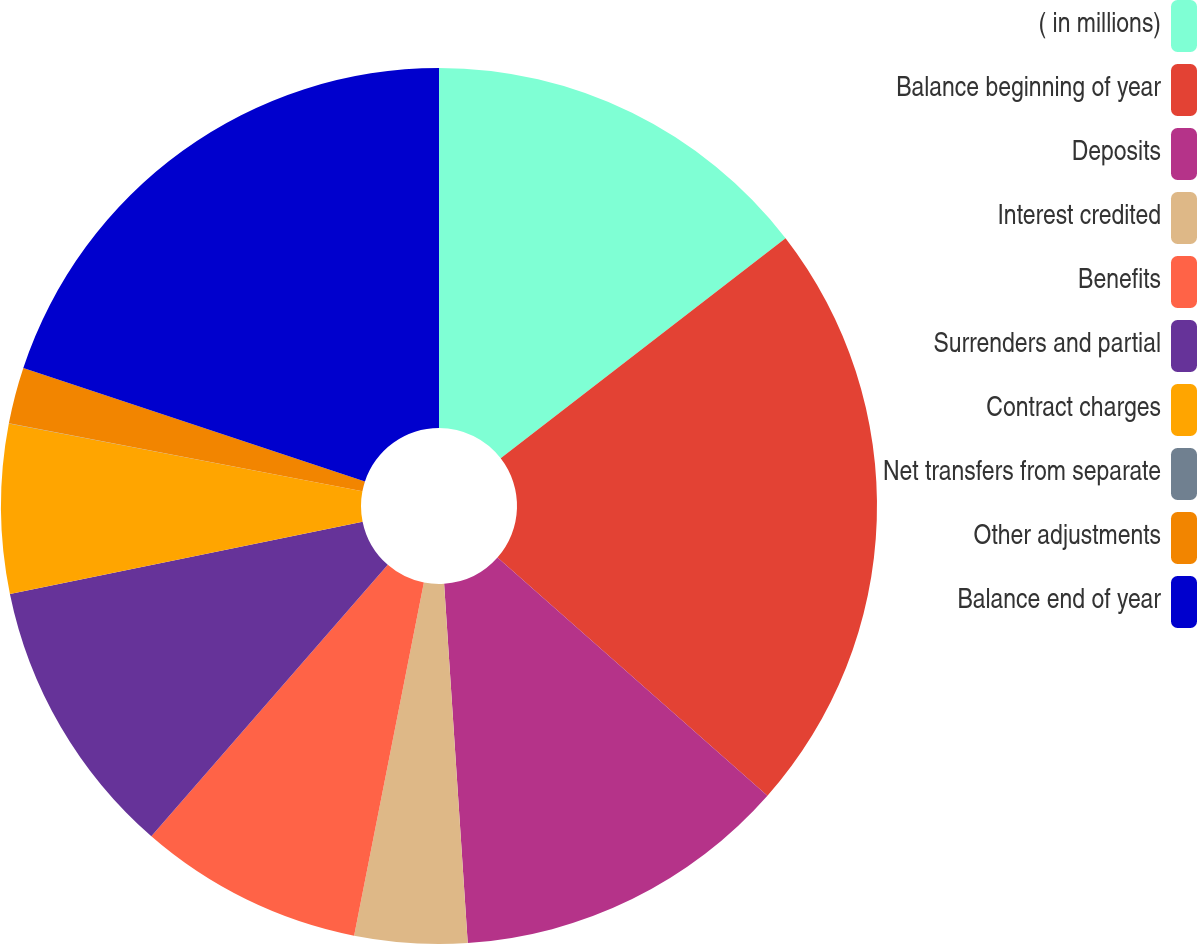Convert chart. <chart><loc_0><loc_0><loc_500><loc_500><pie_chart><fcel>( in millions)<fcel>Balance beginning of year<fcel>Deposits<fcel>Interest credited<fcel>Benefits<fcel>Surrenders and partial<fcel>Contract charges<fcel>Net transfers from separate<fcel>Other adjustments<fcel>Balance end of year<nl><fcel>14.53%<fcel>21.98%<fcel>12.45%<fcel>4.15%<fcel>8.3%<fcel>10.38%<fcel>6.23%<fcel>0.01%<fcel>2.08%<fcel>19.9%<nl></chart> 